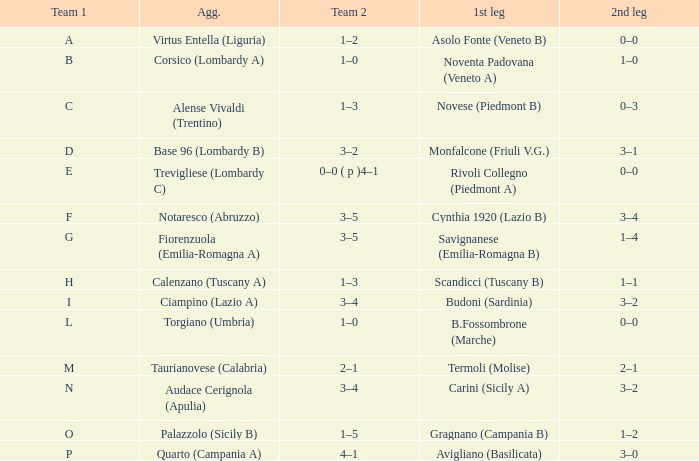What 1st leg has Alense Vivaldi (Trentino) as Agg.? Novese (Piedmont B). 